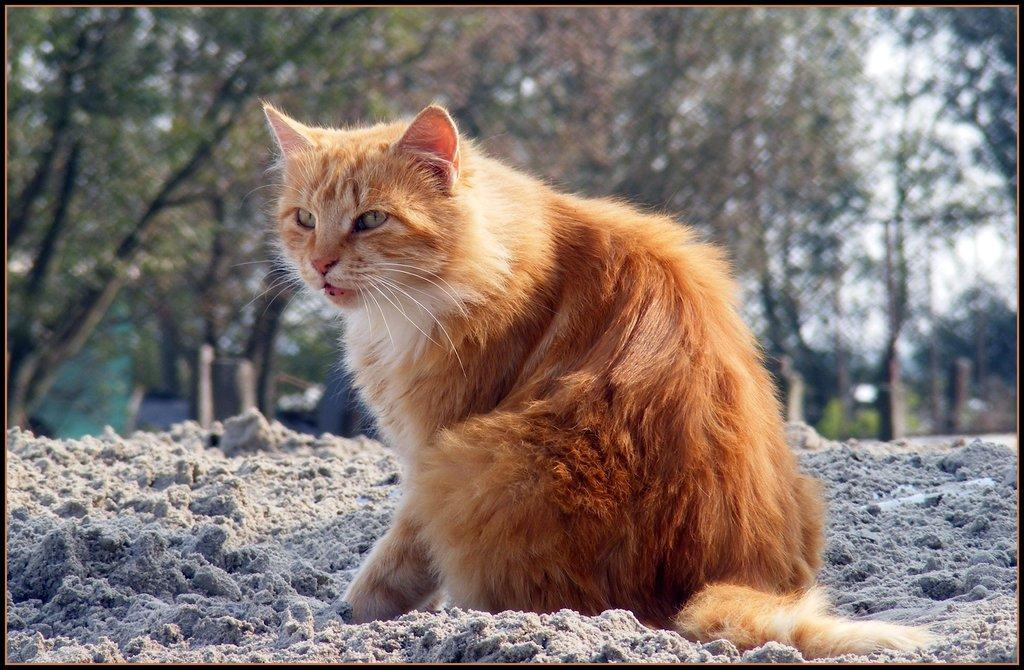What type of animal is in the image? There is a cat in the image. Can you describe the color of the cat? The cat is white and cream in color. What type of terrain is visible in the image? There is sand visible in the image. What can be seen in the background of the image? There are trees in the background of the image. What type of lamp is being used to illuminate the cat in the image? There is no lamp present in the image; the cat is in a sandy area with trees in the background. 